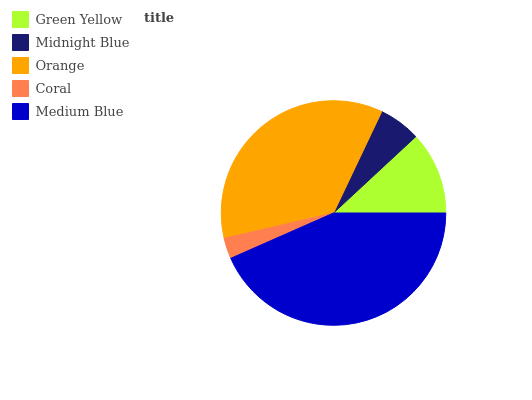Is Coral the minimum?
Answer yes or no. Yes. Is Medium Blue the maximum?
Answer yes or no. Yes. Is Midnight Blue the minimum?
Answer yes or no. No. Is Midnight Blue the maximum?
Answer yes or no. No. Is Green Yellow greater than Midnight Blue?
Answer yes or no. Yes. Is Midnight Blue less than Green Yellow?
Answer yes or no. Yes. Is Midnight Blue greater than Green Yellow?
Answer yes or no. No. Is Green Yellow less than Midnight Blue?
Answer yes or no. No. Is Green Yellow the high median?
Answer yes or no. Yes. Is Green Yellow the low median?
Answer yes or no. Yes. Is Orange the high median?
Answer yes or no. No. Is Midnight Blue the low median?
Answer yes or no. No. 